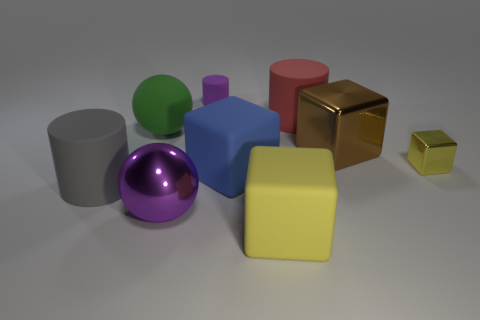Subtract 1 cylinders. How many cylinders are left? 2 Add 1 big brown cubes. How many objects exist? 10 Subtract all green blocks. Subtract all brown spheres. How many blocks are left? 4 Subtract all cubes. How many objects are left? 5 Add 8 big gray rubber cylinders. How many big gray rubber cylinders exist? 9 Subtract 1 green spheres. How many objects are left? 8 Subtract all big purple objects. Subtract all tiny purple matte objects. How many objects are left? 7 Add 2 tiny purple things. How many tiny purple things are left? 3 